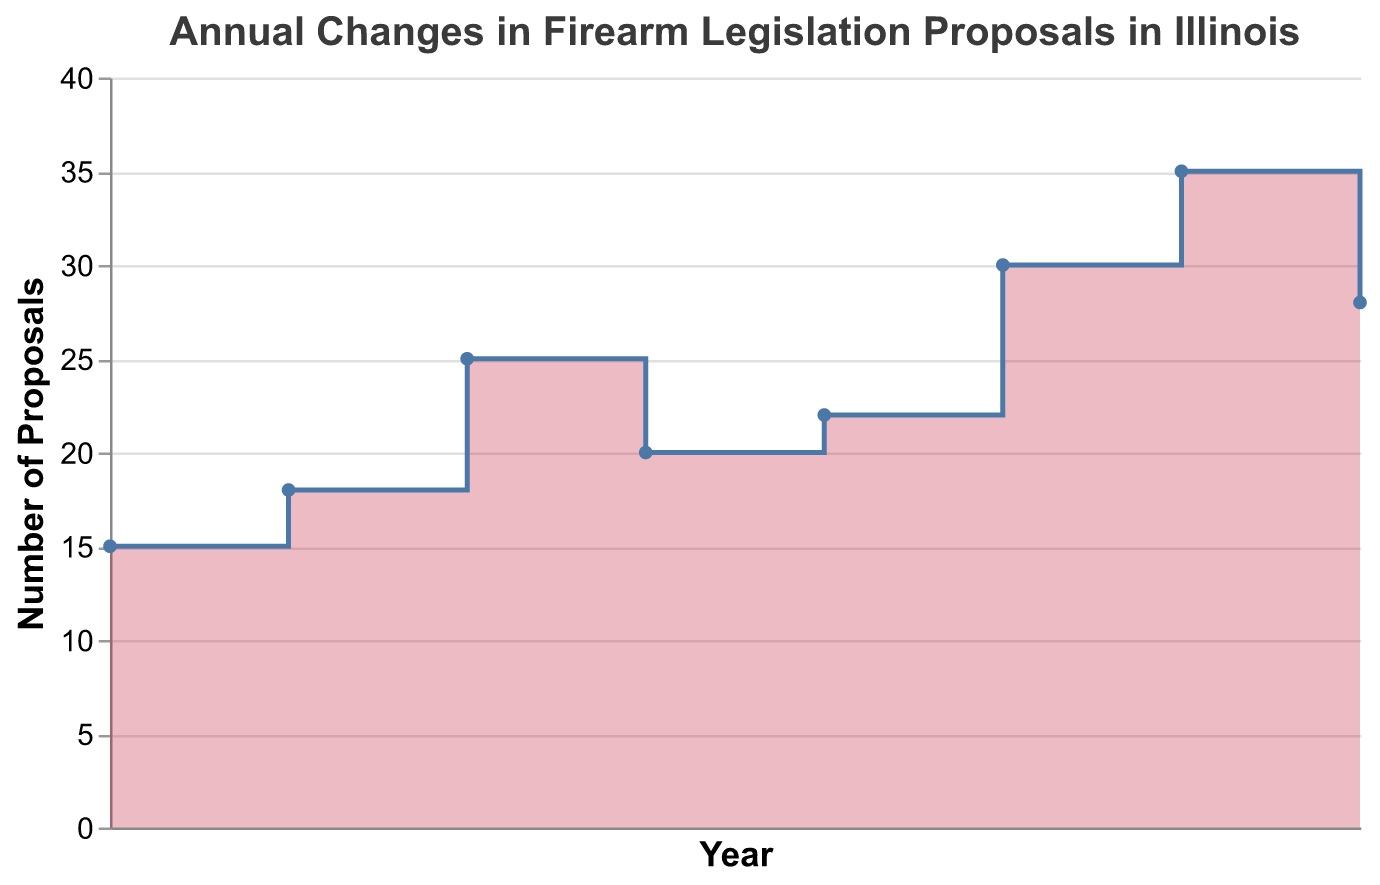* What is the title of the figure? The title of the figure is displayed at the top and reads "Annual Changes in Firearm Legislation Proposals in Illinois".
Answer: Annual Changes in Firearm Legislation Proposals in Illinois * How many proposals were made in 2017? The number of proposals can be found by looking at the y-axis value corresponding to the year 2017 on the x-axis.
Answer: 25 * Which year had the highest number of firearm legislation proposals? By examining the y-axis values across all years, we can see that 2021 had the highest number of proposals, reaching 35.
Answer: 2021 * How does the number of proposals in 2022 compare to 2021? Compare the y-axis value for 2022 and 2021. The number of proposals in 2022 (28) is less than in 2021 (35).
Answer: The number of proposals decreased * What is the difference in the number of proposals between 2015 and 2020? Subtract the number of proposals in 2015 (15) from the number in 2020 (30).
Answer: 15 * What is the average number of proposals from 2015 to 2022? Sum the number of proposals for each year and divide by the number of years: (15 + 18 + 25 + 20 + 22 + 30 + 35 + 28) / 8 = 193 / 8.
Answer: 24.125 * Which year saw a decrease in proposals compared to the previous year? By comparing the number of proposals year-over-year, 2018 saw a decrease compared to 2017 (from 25 to 20) and 2022 saw a decrease compared to 2021 (from 35 to 28).
Answer: 2018 and 2022 * How many years had more than 25 proposals? Identify the years where the y-axis value is greater than 25: 2017, 2020, 2021, and 2022.
Answer: 4 years * What is the cumulative total of proposals from 2015 to 2019? Sum the number of proposals from 2015 to 2019: 15 + 18 + 25 + 20 + 22.
Answer: 100 * In which years did the number of proposals exceed the average number of proposals? First, calculate the average: (15 + 18 + 25 + 20 + 22 + 30 + 35 + 28) / 8 = 24.125. The years where proposals exceeded 24.125 are 2017, 2020, 2021, and 2022.
Answer: 2017, 2020, 2021, and 2022 